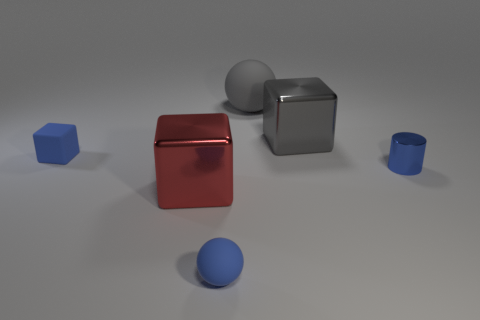Is the number of big cubes in front of the rubber cube greater than the number of tiny brown metallic objects?
Offer a very short reply. Yes. There is a cube that is left of the big red cube to the left of the small blue metal cylinder; what number of blue spheres are to the right of it?
Offer a very short reply. 1. Do the thing on the right side of the big gray metallic object and the red object have the same shape?
Your answer should be compact. No. What is the small blue object on the left side of the small blue ball made of?
Ensure brevity in your answer.  Rubber. What is the shape of the matte thing that is in front of the big gray matte sphere and behind the small blue matte sphere?
Make the answer very short. Cube. What material is the tiny blue cylinder?
Provide a succinct answer. Metal. How many cylinders are small blue rubber objects or tiny metallic objects?
Ensure brevity in your answer.  1. Is the large sphere made of the same material as the tiny blue cylinder?
Make the answer very short. No. The other object that is the same shape as the large rubber thing is what size?
Give a very brief answer. Small. There is a object that is both behind the matte cube and to the right of the gray sphere; what material is it?
Ensure brevity in your answer.  Metal. 